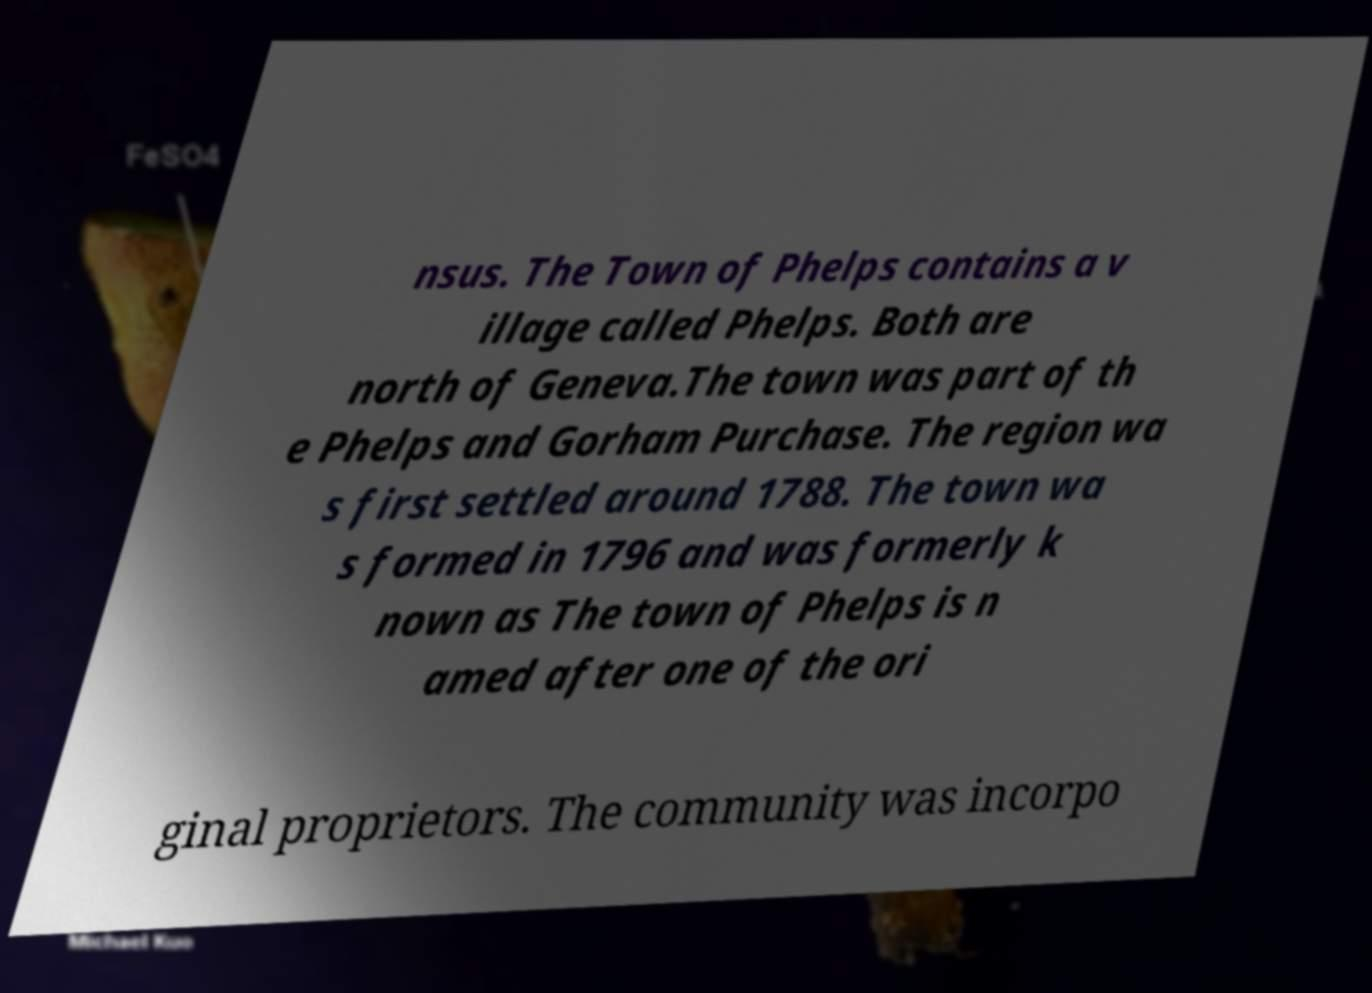Could you extract and type out the text from this image? nsus. The Town of Phelps contains a v illage called Phelps. Both are north of Geneva.The town was part of th e Phelps and Gorham Purchase. The region wa s first settled around 1788. The town wa s formed in 1796 and was formerly k nown as The town of Phelps is n amed after one of the ori ginal proprietors. The community was incorpo 